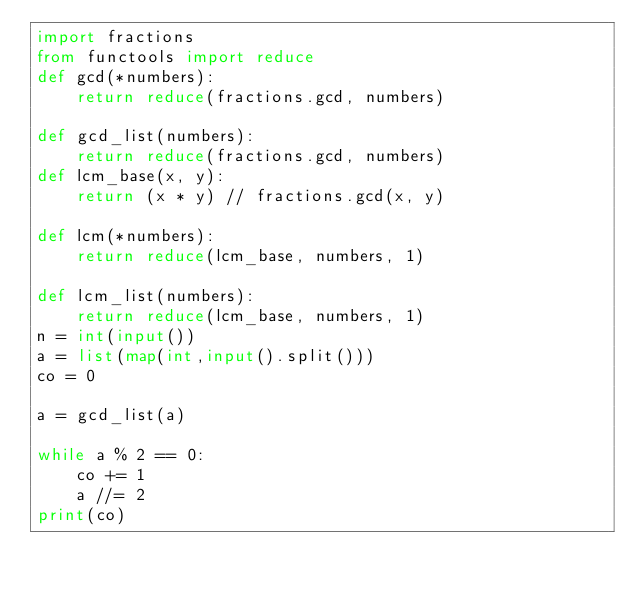Convert code to text. <code><loc_0><loc_0><loc_500><loc_500><_Python_>import fractions
from functools import reduce
def gcd(*numbers):
    return reduce(fractions.gcd, numbers)

def gcd_list(numbers):
    return reduce(fractions.gcd, numbers)
def lcm_base(x, y):
    return (x * y) // fractions.gcd(x, y)

def lcm(*numbers):
    return reduce(lcm_base, numbers, 1)

def lcm_list(numbers):
    return reduce(lcm_base, numbers, 1)
n = int(input())
a = list(map(int,input().split()))
co = 0

a = gcd_list(a)

while a % 2 == 0:
    co += 1
    a //= 2
print(co)</code> 